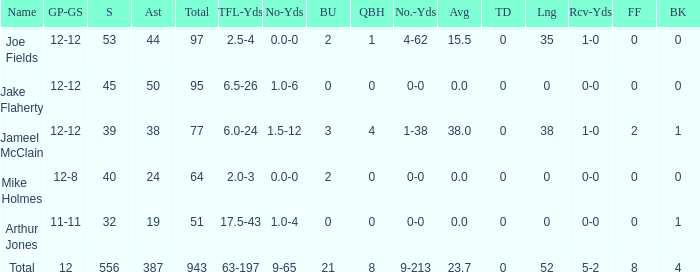What is the total brup for the team? 21.0. 